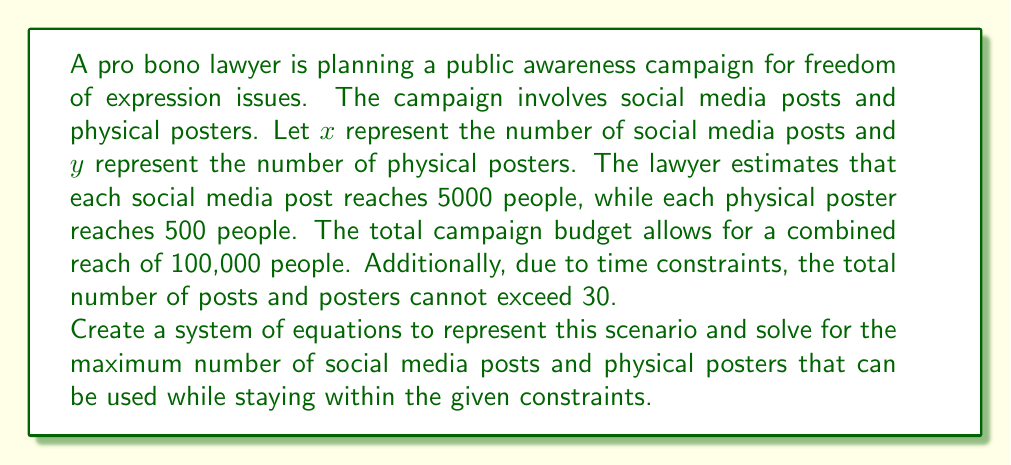Give your solution to this math problem. Let's approach this step-by-step:

1) First, we need to set up our system of equations based on the given information:

   Equation 1 (reach constraint): $5000x + 500y = 100000$
   Equation 2 (time constraint): $x + y \leq 30$

2) Simplify Equation 1:
   $5000x + 500y = 100000$
   $10x + y = 200$

3) Now we have a system:
   $10x + y = 200$
   $x + y \leq 30$

4) To maximize the number of posts and posters, we want to find the point where both equations are satisfied and $x + y$ is as close to 30 as possible.

5) Let's solve the first equation for y:
   $y = 200 - 10x$

6) Substitute this into the second equation:
   $x + (200 - 10x) \leq 30$
   $200 - 9x \leq 30$
   $-9x \leq -170$
   $x \geq 18.89$

7) Since $x$ must be an integer, the maximum value it can take is 18.

8) Substituting $x = 18$ back into $y = 200 - 10x$:
   $y = 200 - 10(18) = 20$

9) Check if this satisfies the time constraint:
   $18 + 20 = 38$, which is greater than 30.

10) We need to reduce either $x$ or $y$. Reducing $y$ will have less impact on the total reach. Let's try $x = 18$ and $y = 12$:
    $18 + 12 = 30$, which satisfies the time constraint.

11) Verify the reach constraint:
    $5000(18) + 500(12) = 90000 + 6000 = 96000$, which is less than 100000 but close to the maximum.

Therefore, the optimal solution is 18 social media posts and 12 physical posters.
Answer: The maximum number of social media posts is 18, and the maximum number of physical posters is 12. 